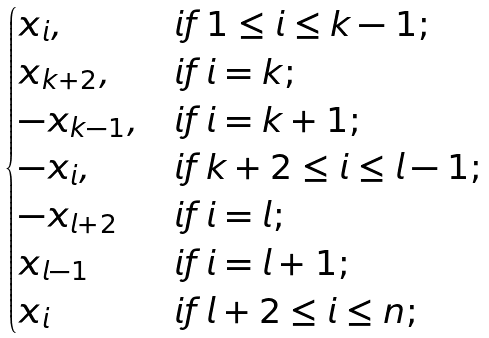<formula> <loc_0><loc_0><loc_500><loc_500>\begin{cases} x _ { i } , & i f \, 1 \leq i \leq k - 1 ; \\ x _ { k + 2 } , & i f \, i = k ; \\ - x _ { k - 1 } , & i f \, i = k + 1 ; \\ - x _ { i } , & i f \, k + 2 \leq i \leq l - 1 ; \\ - x _ { l + 2 } & i f \, i = l ; \\ x _ { l - 1 } & i f \, i = l + 1 ; \\ x _ { i } & i f \, l + 2 \leq i \leq n ; \end{cases}</formula> 